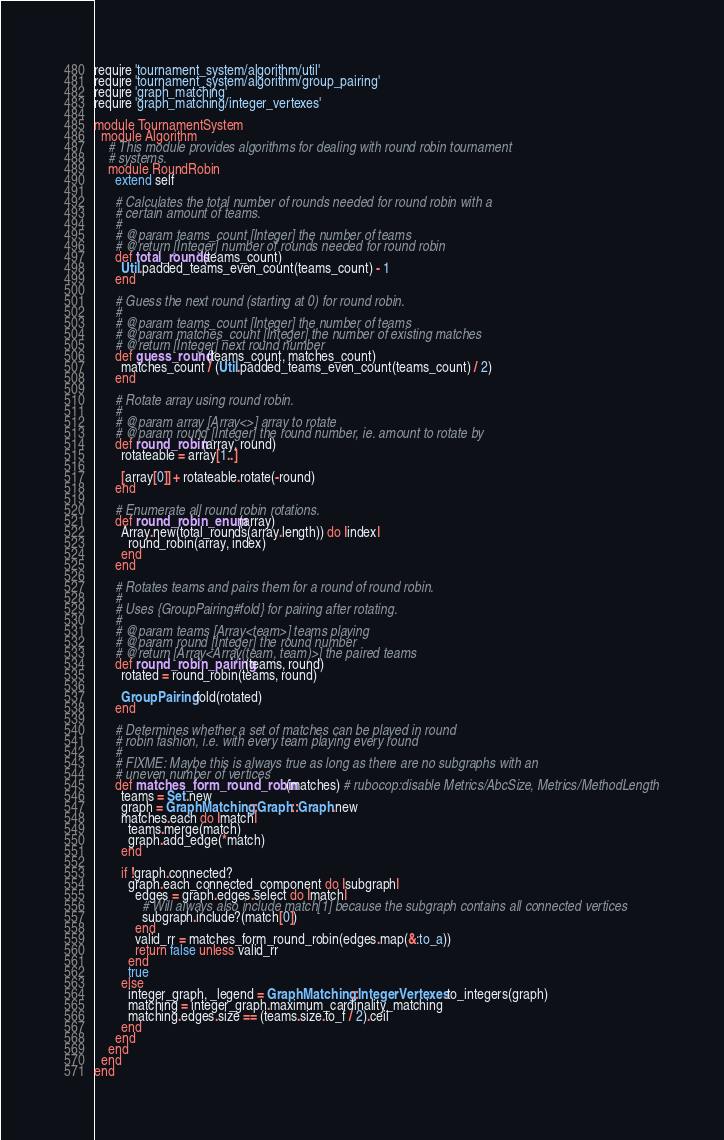Convert code to text. <code><loc_0><loc_0><loc_500><loc_500><_Ruby_>require 'tournament_system/algorithm/util'
require 'tournament_system/algorithm/group_pairing'
require 'graph_matching'
require 'graph_matching/integer_vertexes'

module TournamentSystem
  module Algorithm
    # This module provides algorithms for dealing with round robin tournament
    # systems.
    module RoundRobin
      extend self

      # Calculates the total number of rounds needed for round robin with a
      # certain amount of teams.
      #
      # @param teams_count [Integer] the number of teams
      # @return [Integer] number of rounds needed for round robin
      def total_rounds(teams_count)
        Util.padded_teams_even_count(teams_count) - 1
      end

      # Guess the next round (starting at 0) for round robin.
      #
      # @param teams_count [Integer] the number of teams
      # @param matches_count [Integer] the number of existing matches
      # @return [Integer] next round number
      def guess_round(teams_count, matches_count)
        matches_count / (Util.padded_teams_even_count(teams_count) / 2)
      end

      # Rotate array using round robin.
      #
      # @param array [Array<>] array to rotate
      # @param round [Integer] the round number, ie. amount to rotate by
      def round_robin(array, round)
        rotateable = array[1..]

        [array[0]] + rotateable.rotate(-round)
      end

      # Enumerate all round robin rotations.
      def round_robin_enum(array)
        Array.new(total_rounds(array.length)) do |index|
          round_robin(array, index)
        end
      end

      # Rotates teams and pairs them for a round of round robin.
      #
      # Uses {GroupPairing#fold} for pairing after rotating.
      #
      # @param teams [Array<team>] teams playing
      # @param round [Integer] the round number
      # @return [Array<Array(team, team)>] the paired teams
      def round_robin_pairing(teams, round)
        rotated = round_robin(teams, round)

        GroupPairing.fold(rotated)
      end

      # Determines whether a set of matches can be played in round
      # robin fashion, i.e. with every team playing every round
      #
      # FIXME: Maybe this is always true as long as there are no subgraphs with an
      # uneven number of vertices
      def matches_form_round_robin(matches) # rubocop:disable Metrics/AbcSize, Metrics/MethodLength
        teams = Set.new
        graph = GraphMatching::Graph::Graph.new
        matches.each do |match|
          teams.merge(match)
          graph.add_edge(*match)
        end

        if !graph.connected?
          graph.each_connected_component do |subgraph|
            edges = graph.edges.select do |match|
              # Will always also include match[1] because the subgraph contains all connected vertices
              subgraph.include?(match[0])
            end
            valid_rr = matches_form_round_robin(edges.map(&:to_a))
            return false unless valid_rr
          end
          true
        else
          integer_graph, _legend = GraphMatching::IntegerVertexes.to_integers(graph)
          matching = integer_graph.maximum_cardinality_matching
          matching.edges.size == (teams.size.to_f / 2).ceil
        end
      end
    end
  end
end
</code> 